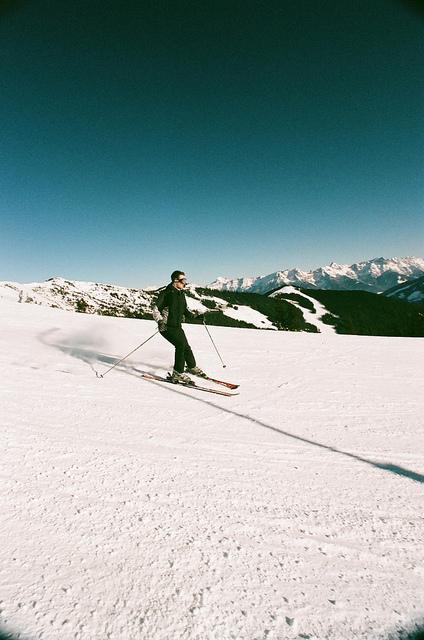What direction is the man skiing?
Be succinct. Downhill. What is the skier holding?
Quick response, please. Poles. How packed is the snow for skiing?
Answer briefly. Packed. Is the man snowboarding?
Concise answer only. No. Which direction is the man pointed?
Write a very short answer. Right. 